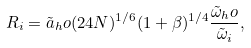Convert formula to latex. <formula><loc_0><loc_0><loc_500><loc_500>R _ { i } = \tilde { a } _ { h } o ( 2 4 N ) ^ { 1 / 6 } ( 1 + \beta ) ^ { 1 / 4 } \frac { \tilde { \omega } _ { h } o } { \tilde { \omega } _ { i } } ,</formula> 